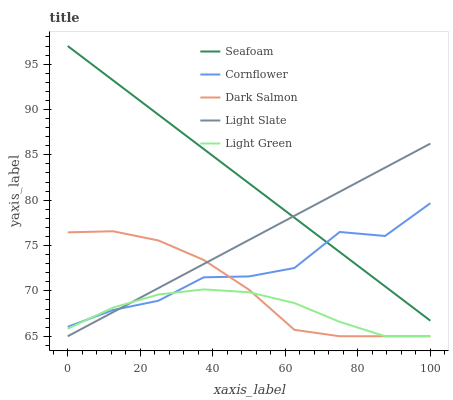Does Light Green have the minimum area under the curve?
Answer yes or no. Yes. Does Seafoam have the maximum area under the curve?
Answer yes or no. Yes. Does Cornflower have the minimum area under the curve?
Answer yes or no. No. Does Cornflower have the maximum area under the curve?
Answer yes or no. No. Is Seafoam the smoothest?
Answer yes or no. Yes. Is Cornflower the roughest?
Answer yes or no. Yes. Is Cornflower the smoothest?
Answer yes or no. No. Is Seafoam the roughest?
Answer yes or no. No. Does Light Slate have the lowest value?
Answer yes or no. Yes. Does Cornflower have the lowest value?
Answer yes or no. No. Does Seafoam have the highest value?
Answer yes or no. Yes. Does Cornflower have the highest value?
Answer yes or no. No. Is Dark Salmon less than Seafoam?
Answer yes or no. Yes. Is Seafoam greater than Dark Salmon?
Answer yes or no. Yes. Does Dark Salmon intersect Cornflower?
Answer yes or no. Yes. Is Dark Salmon less than Cornflower?
Answer yes or no. No. Is Dark Salmon greater than Cornflower?
Answer yes or no. No. Does Dark Salmon intersect Seafoam?
Answer yes or no. No. 